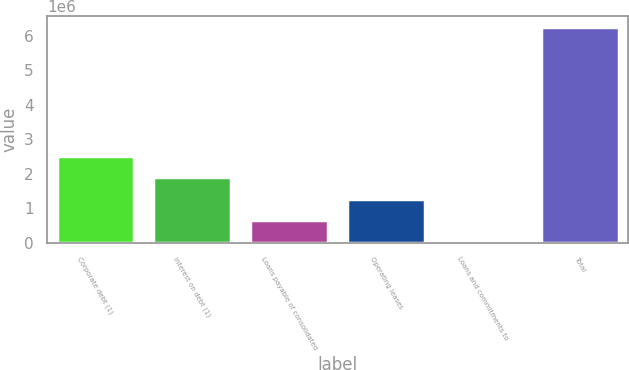<chart> <loc_0><loc_0><loc_500><loc_500><bar_chart><fcel>Corporate debt (1)<fcel>Interest on debt (1)<fcel>Loans payable of consolidated<fcel>Operating leases<fcel>Loans and commitments to<fcel>Total<nl><fcel>2.52196e+06<fcel>1.8998e+06<fcel>655494<fcel>1.27765e+06<fcel>33340<fcel>6.25488e+06<nl></chart> 